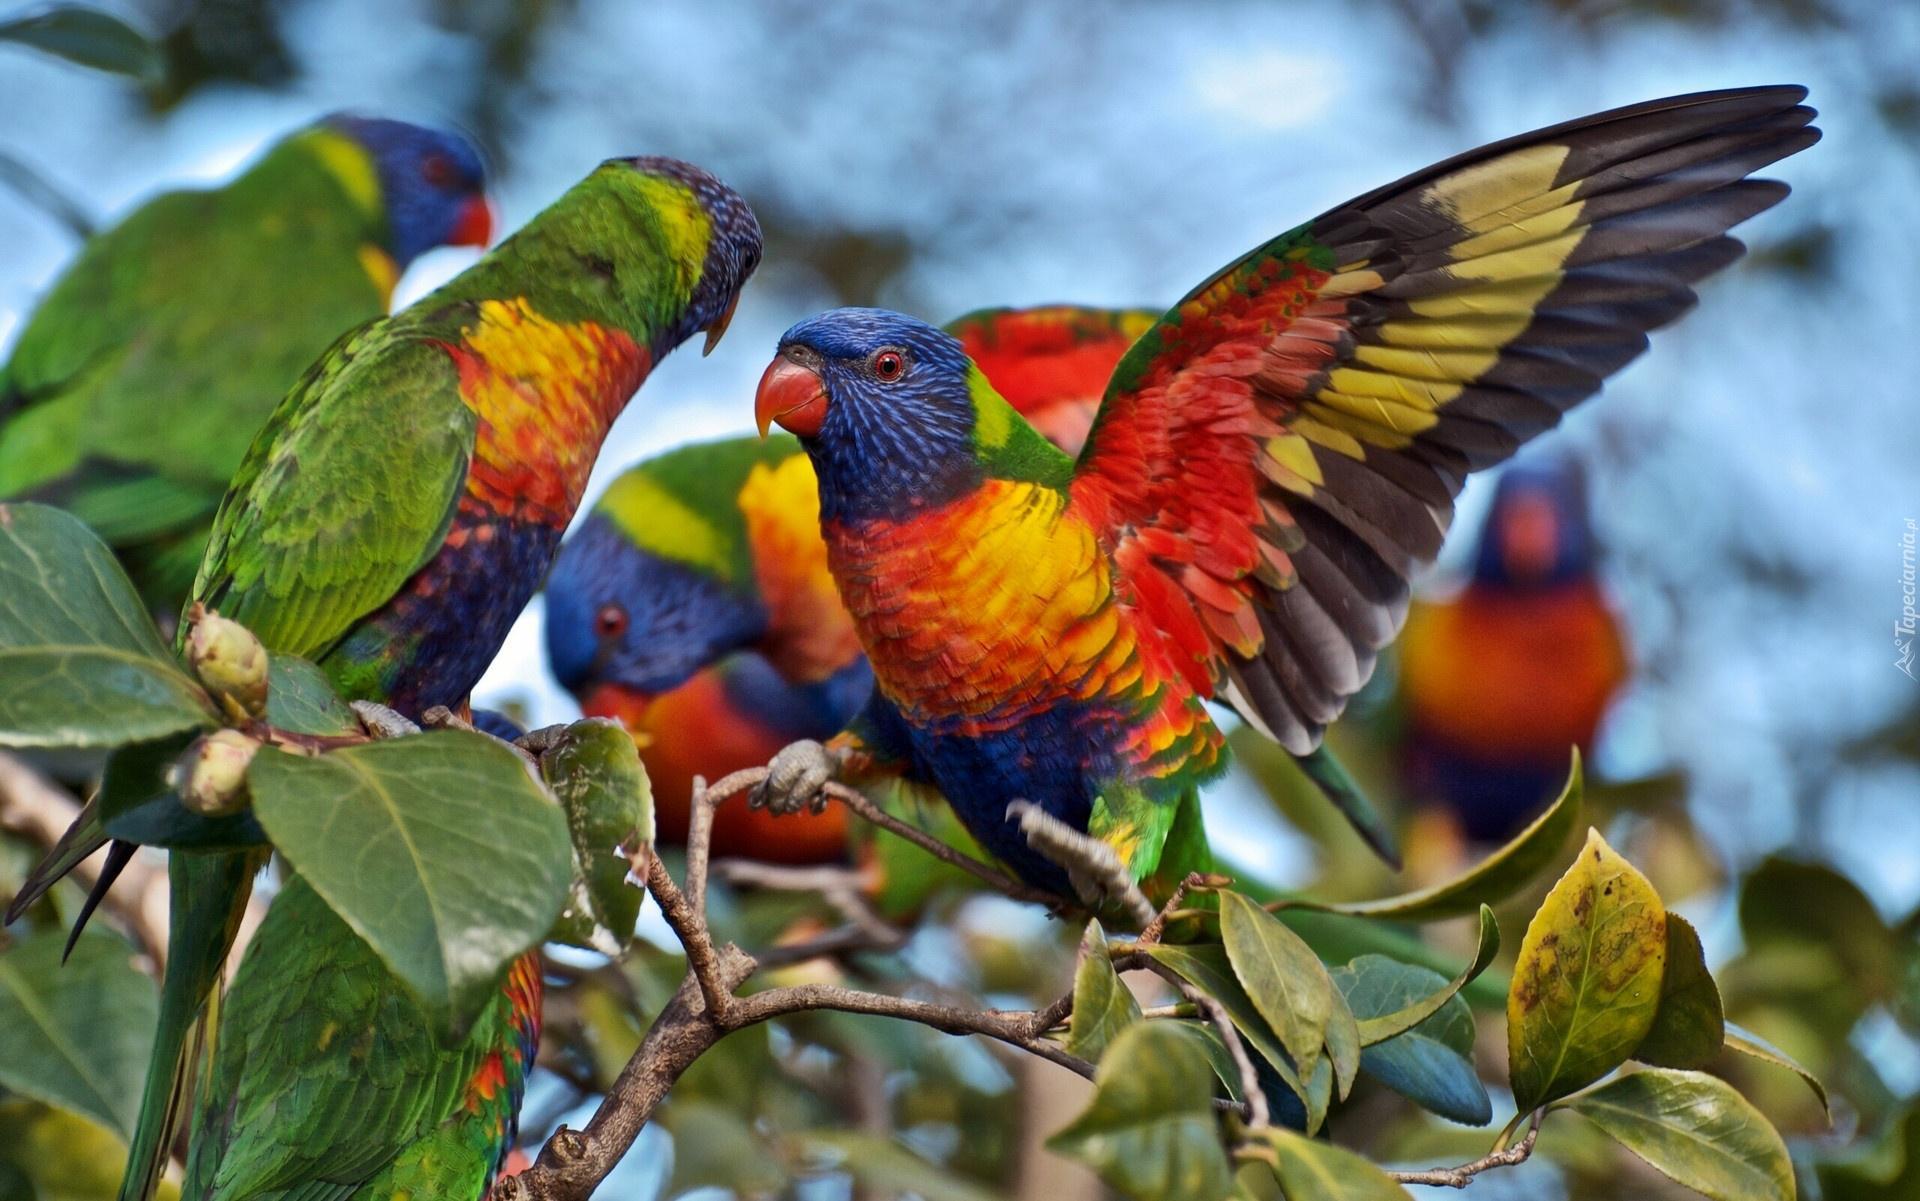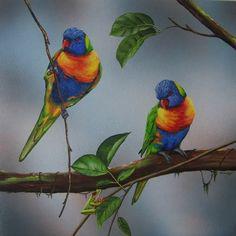The first image is the image on the left, the second image is the image on the right. Given the left and right images, does the statement "All of the images contain at least two parrots." hold true? Answer yes or no. Yes. 